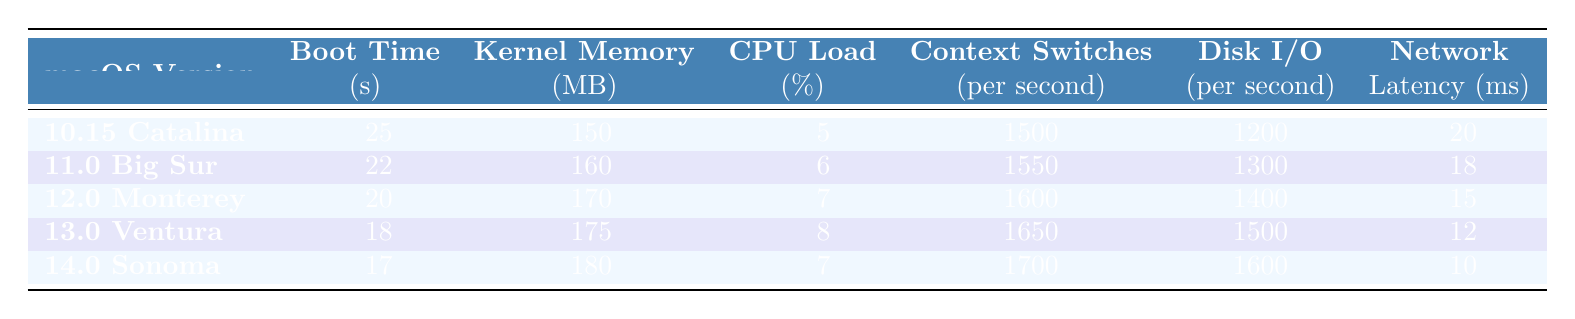What is the boot time for macOS 12.0 Monterey? The table directly lists the boot time for macOS 12.0 Monterey as 20 seconds.
Answer: 20 seconds Which macOS version has the highest kernel memory usage? By comparing the kernel memory usage for each version in the table, macOS 14.0 Sonoma has the highest usage at 180 MB.
Answer: macOS 14.0 Sonoma Is the network latency for macOS 13.0 Ventura lower than for macOS 10.15 Catalina? The network latency for macOS 13.0 Ventura is 12 ms, while for macOS 10.15 Catalina it is 20 ms. Since 12 ms is less than 20 ms, the statement is true.
Answer: Yes What is the average CPU load across all macOS versions listed? To find the average CPU load, sum the CPU load values (5 + 6 + 7 + 8 + 7 = 33) and divide by the number of versions (5): 33 / 5 = 6.6%.
Answer: 6.6% Which macOS version has the lowest disk I/O operations per second? Reviewing the disk I/O operations per second for each macOS version in the table shows that macOS 10.15 Catalina has the lowest at 1200 operations.
Answer: macOS 10.15 Catalina What is the difference in boot time between the latest macOS version and the earliest? The boot time for macOS 14.0 Sonoma is 17 seconds, and for macOS 10.15 Catalina, it is 25 seconds. The difference is 25 - 17 = 8 seconds.
Answer: 8 seconds Can you identify if there is an increase in context switches per second from macOS 11.0 Big Sur to macOS 12.0 Monterey? For macOS 11.0 Big Sur, context switches per second are 1550, and for macOS 12.0 Monterey, it is 1600. Since 1600 is greater than 1550, there is an increase.
Answer: Yes If you were to rank the macOS versions by networking latency, which would rank third? Listing the network latency values in ascending order: 10 ms (Sonoma), 12 ms (Ventura), 15 ms (Monterey), 18 ms (Big Sur), 20 ms (Catalina). The third-highest is 15 ms for macOS 12.0 Monterey.
Answer: macOS 12.0 Monterey What is the total kernel memory usage for the three most recent macOS versions? The kernel memory usage for the three most recent versions (Monterey, Ventura, and Sonoma) is: 170 MB + 175 MB + 180 MB = 525 MB.
Answer: 525 MB Is the CPU load for macOS 13.0 Ventura greater than the average CPU load of the list? The CPU load for macOS 13.0 Ventura is 8%, and the average CPU load is 6.6%. Since 8% is greater than 6.6%, the statement is true.
Answer: Yes 